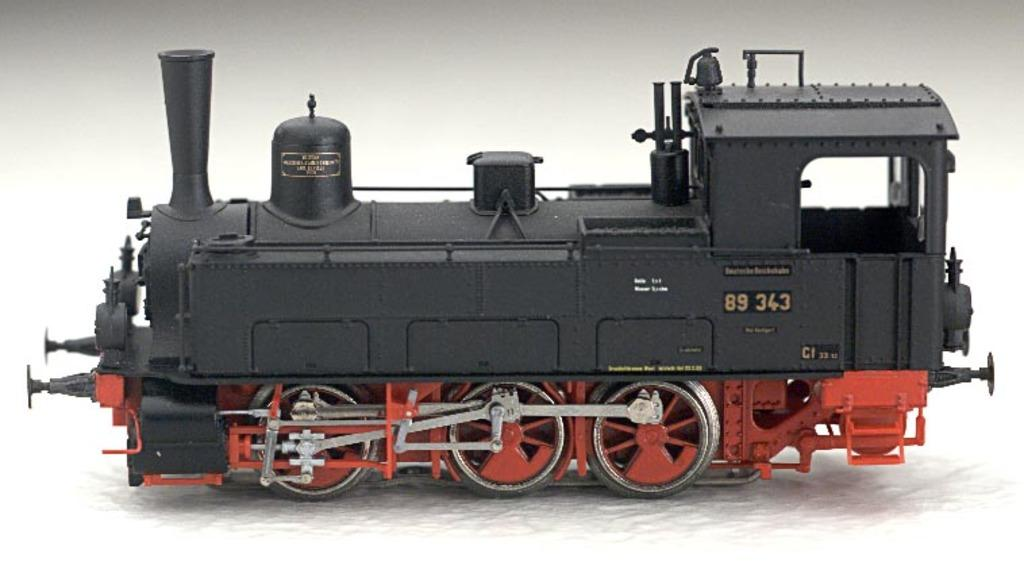What type of toy is present in the image? There is a toy steam engine in the image. What type of zinc is visible in the image? There is no zinc present in the image; it features a toy steam engine. 